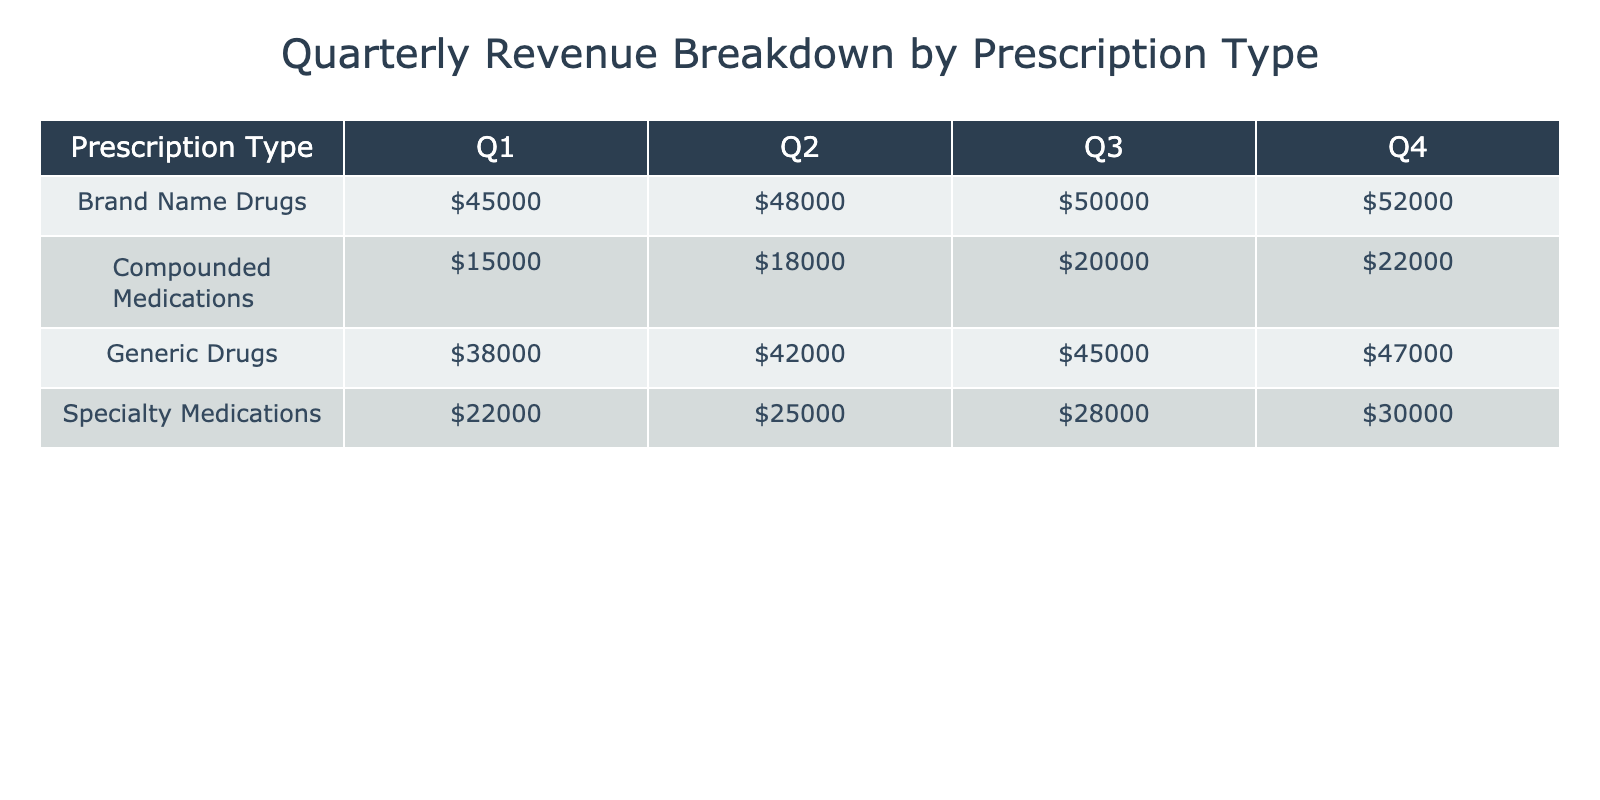What was the total revenue for Brand Name Drugs in Q3? The table shows revenue of $50000 for Brand Name Drugs in Q3. There are no other entries under this category for Q3.
Answer: $50000 What is the revenue for Compounded Medications in Q4? The table indicates that the revenue for Compounded Medications in Q4 is $22000.
Answer: $22000 Which prescription type had the highest revenue in Q2? By reviewing the table, the highest revenue in Q2 is for Brand Name Drugs at $48000, compared to others.
Answer: Brand Name Drugs What was the average revenue of Specialty Medications across all quarters? The revenue for Specialty Medications are $22000 (Q1), $25000 (Q2), $28000 (Q3), and $30000 (Q4). Summing these values gives $22000 + $25000 + $28000 + $30000 = $105000. Dividing by 4 (quarters) gives an average of $105000 / 4 = $26250.
Answer: $26250 Did Generic Drugs make more revenue in Q1 than in Q2? In Q1, Generic Drugs earned $38000 while in Q2, they earned $42000. Since $42000 is greater than $38000, the answer is no.
Answer: No What is the total revenue of OTC products in Q1? The OTC product revenues in Q1 are Pain Relief ($45000), Cold & Flu ($38000), Vitamins & Supplements ($22000), and Digestive Health ($15000). Adding these amounts gives $45000 + $38000 + $22000 + $15000 = $118000.
Answer: $118000 Which quarter had the lowest total revenue for Compounded Medications? The table shows the revenues for Compounded Medications: $15000 (Q1), $18000 (Q2), $20000 (Q3), $22000 (Q4). The lowest value is $15000 in Q1.
Answer: Q1 What is the change in revenue from Q1 to Q4 for Brand Name Drugs? In Q1, Brand Name Drugs generated $45000, while in Q4, it generated $52000. The change can be calculated as $52000 - $45000 = $7000.
Answer: $7000 Which OTC category had the highest revenue in Q3? The OTC revenues in Q3 are Eye Care ($50000), Oral Care ($45000), Foot Care ($28000), and Baby Care ($20000). Eye Care has the highest revenue of $50000.
Answer: Eye Care Was the revenue for Generic Drugs in Q4 greater than or equal to that of Specialty Medications in Q2? Generic Drugs had $47000 revenue in Q4, while Specialty Medications had $25000 in Q2. Since $47000 is greater than $25000, the answer is yes.
Answer: Yes 